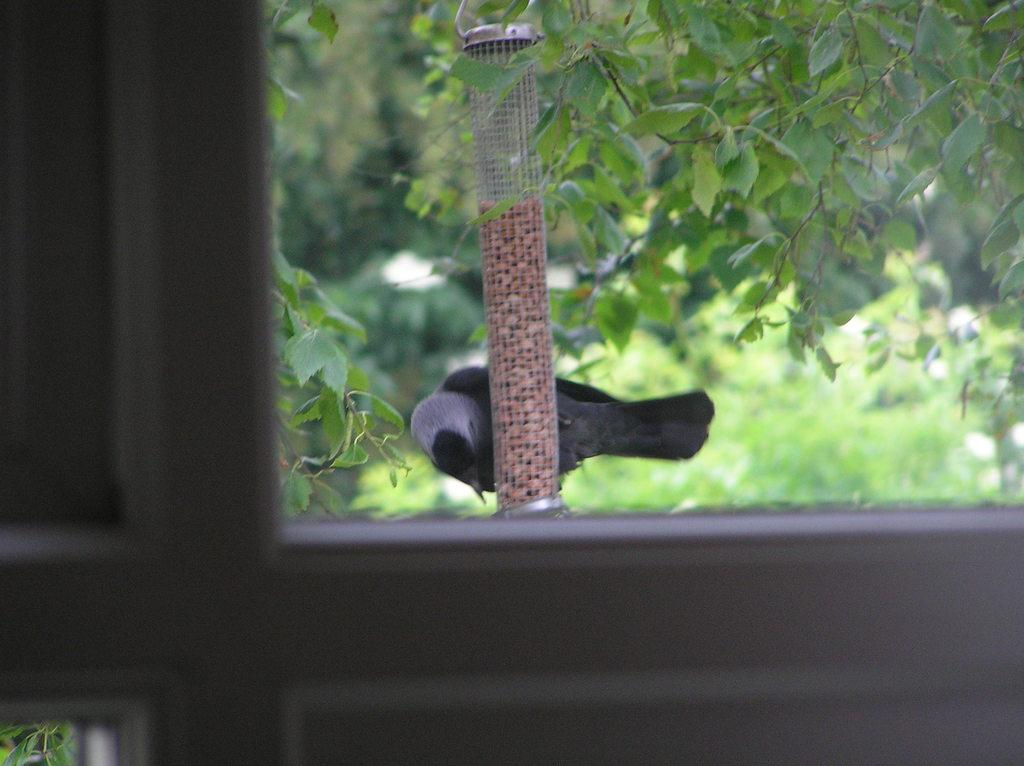What is the main subject in the center of the image? There is a bird in the center of the image. What is the bird interacting with in the image? The bird is interacting with a bird feeder in the image. What can be seen in the background of the image? There are trees in the background of the image. What is visible in the foreground of the image? There is a window in the foreground of the image. How many pigs are visible in the image? There are no pigs present in the image. What type of growth can be seen on the trees in the image? The provided facts do not mention any specific growth on the trees, so it cannot be determined from the image. 